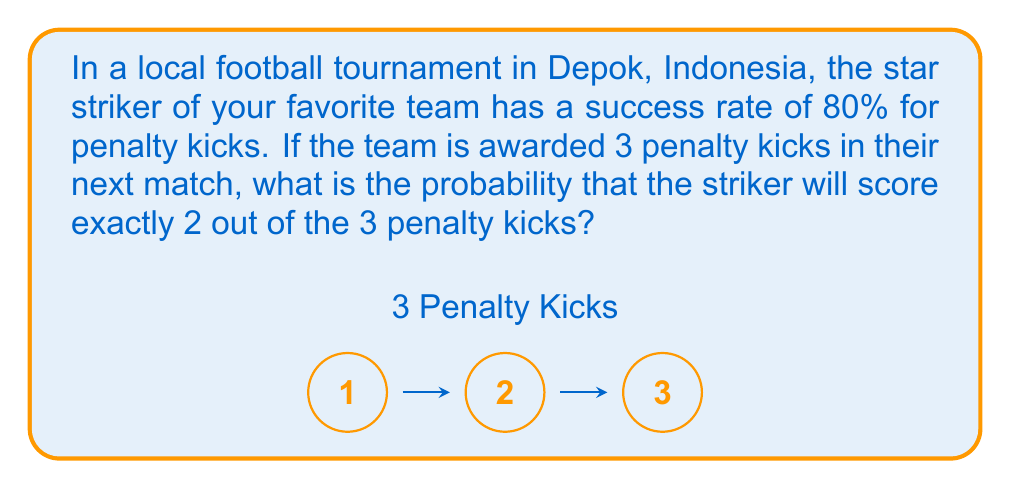Can you answer this question? Let's approach this step-by-step using the binomial probability formula:

1) We can model this scenario as a binomial distribution:
   - n = 3 (number of trials/penalty kicks)
   - k = 2 (number of successes we're interested in)
   - p = 0.80 (probability of success on each trial)

2) The binomial probability formula is:

   $$P(X = k) = \binom{n}{k} p^k (1-p)^{n-k}$$

3) Let's calculate each part:
   
   $$\binom{n}{k} = \binom{3}{2} = \frac{3!}{2!(3-2)!} = \frac{3 \cdot 2 \cdot 1}{(2 \cdot 1)(1)} = 3$$

   $$p^k = 0.80^2 = 0.64$$

   $$(1-p)^{n-k} = (1-0.80)^{3-2} = 0.20^1 = 0.20$$

4) Now, let's put it all together:

   $$P(X = 2) = 3 \cdot 0.64 \cdot 0.20 = 0.384$$

5) Therefore, the probability of scoring exactly 2 out of 3 penalty kicks is 0.384 or 38.4%.
Answer: 0.384 